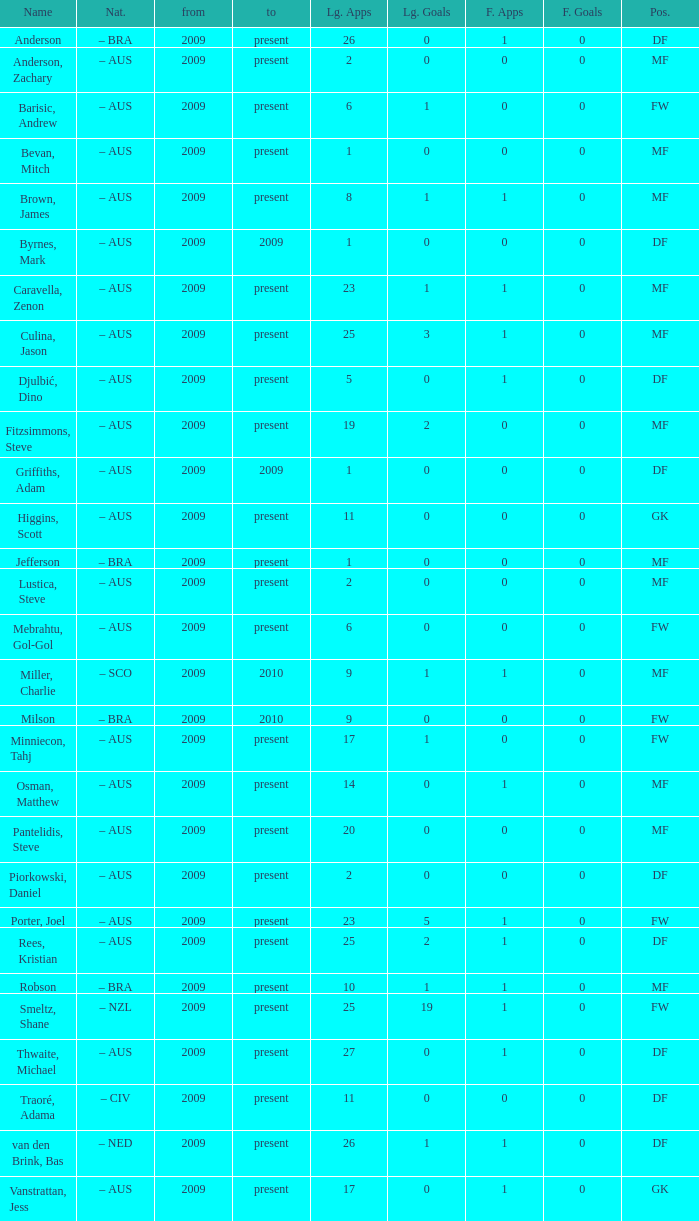What are the top 19 league applications? Present. 